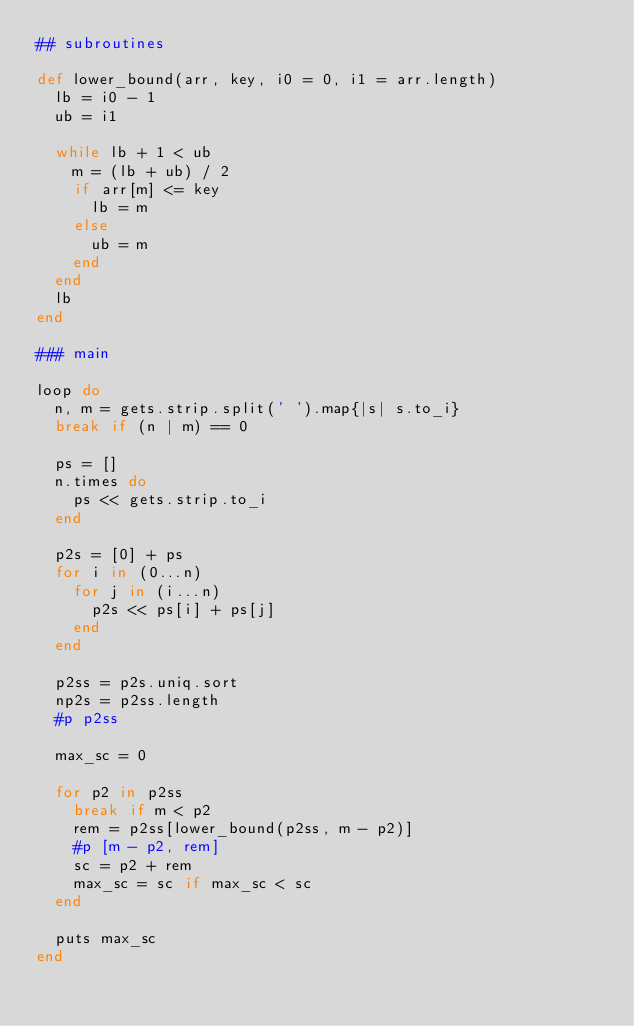Convert code to text. <code><loc_0><loc_0><loc_500><loc_500><_Ruby_>## subroutines

def lower_bound(arr, key, i0 = 0, i1 = arr.length)
  lb = i0 - 1
  ub = i1

  while lb + 1 < ub
    m = (lb + ub) / 2
    if arr[m] <= key
      lb = m
    else
      ub = m
    end
  end
  lb
end

### main

loop do
  n, m = gets.strip.split(' ').map{|s| s.to_i}
  break if (n | m) == 0

  ps = []
  n.times do
    ps << gets.strip.to_i
  end

  p2s = [0] + ps
  for i in (0...n)
    for j in (i...n)
      p2s << ps[i] + ps[j]
    end
  end

  p2ss = p2s.uniq.sort
  np2s = p2ss.length
  #p p2ss

  max_sc = 0

  for p2 in p2ss
    break if m < p2
    rem = p2ss[lower_bound(p2ss, m - p2)]
    #p [m - p2, rem]
    sc = p2 + rem
    max_sc = sc if max_sc < sc
  end

  puts max_sc
end</code> 